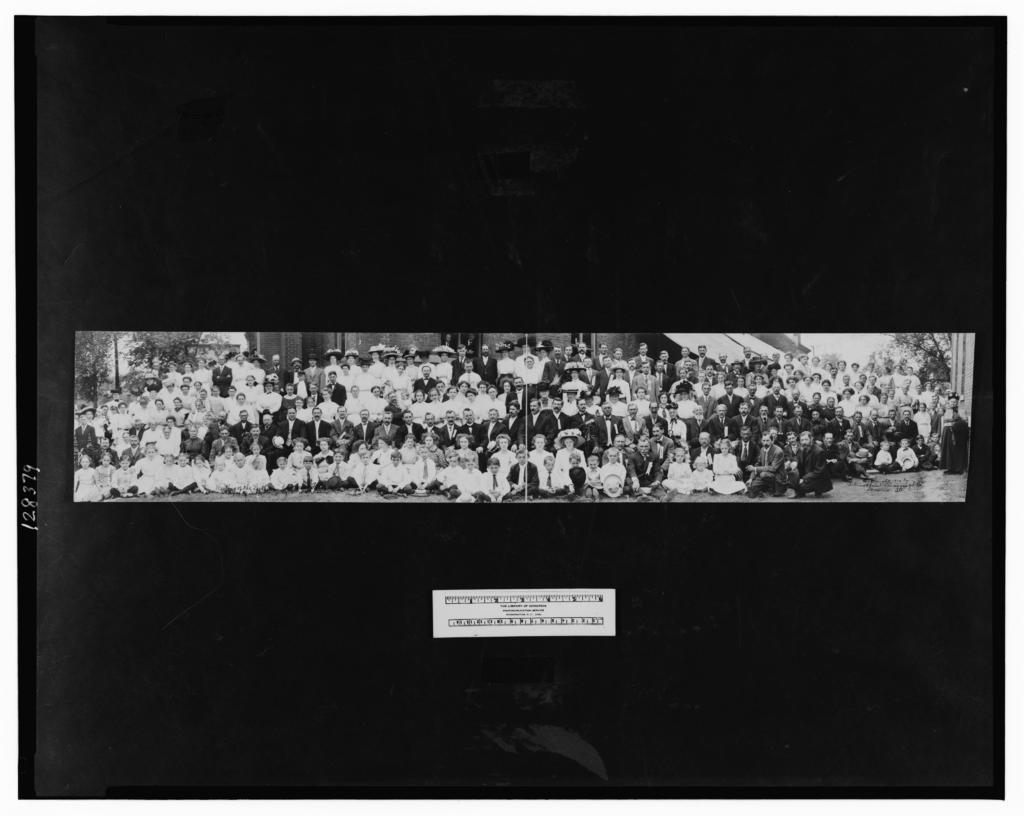What type of picture is in the image? The image contains a black and white picture. Who or what is depicted in the picture? There are people in the picture. What are some of the people in the picture doing? Some of the people are sitting, and some are standing. What can be seen in the background of the picture? There are trees and the sky visible in the background of the picture. Can you tell me how many ants are crawling on the lawyer's desk in the image? There are no ants or lawyers present in the image; it features a black and white picture of people, some of whom are sitting and standing. 